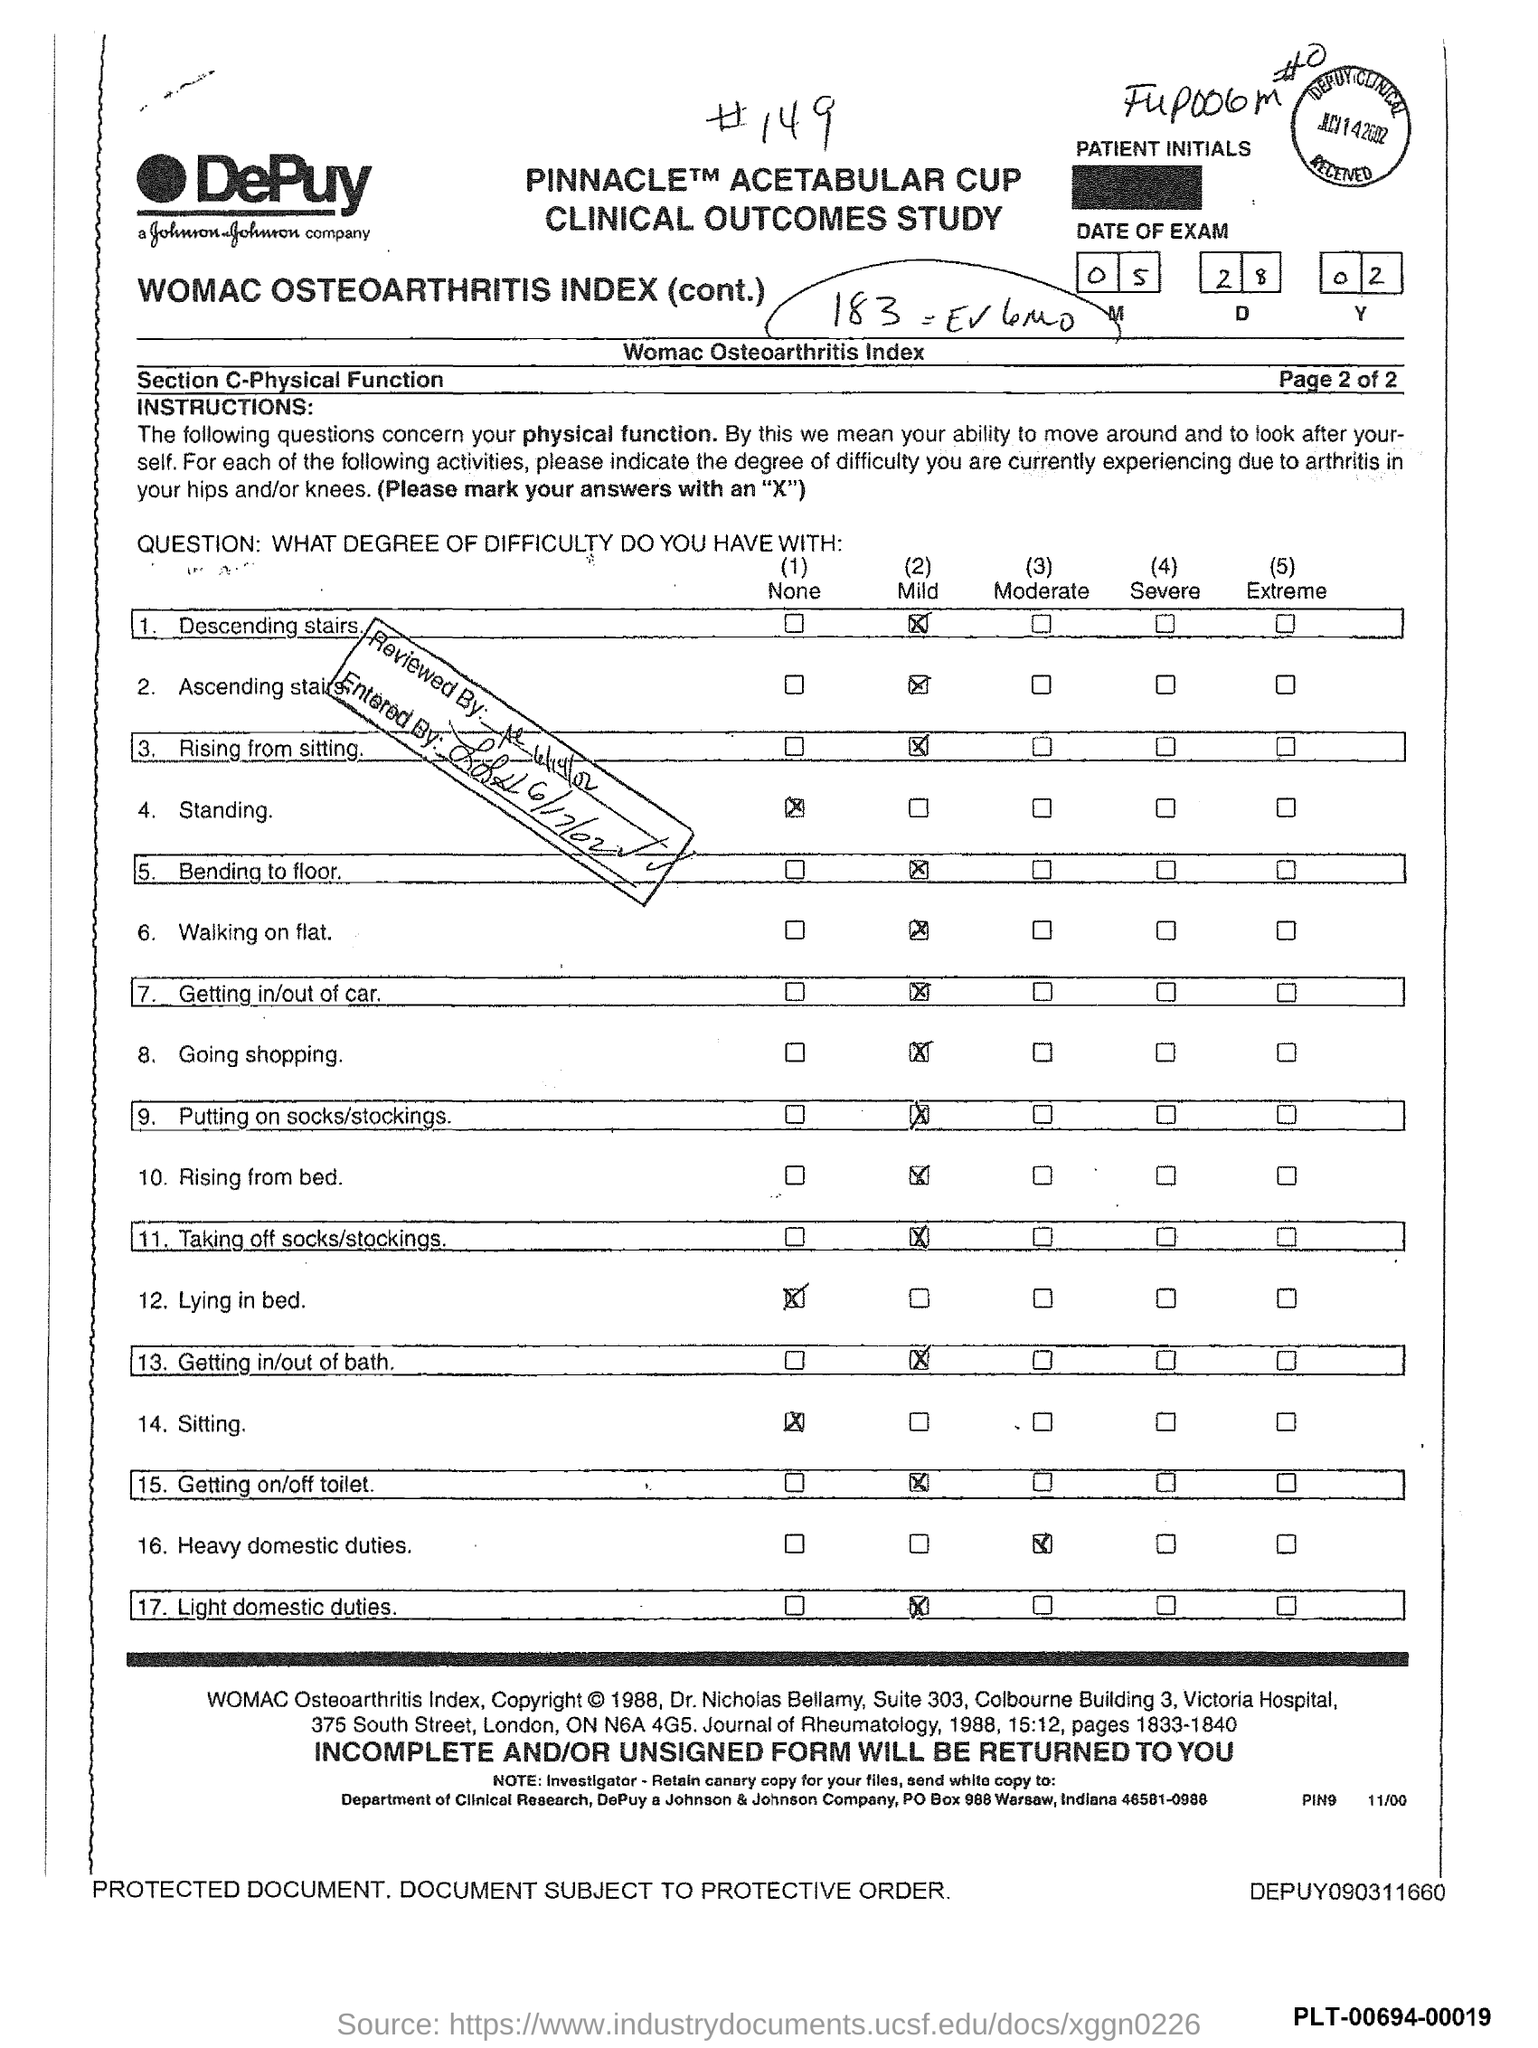Outline some significant characteristics in this image. The date of the exam as mentioned in the document is 05 28 02. 